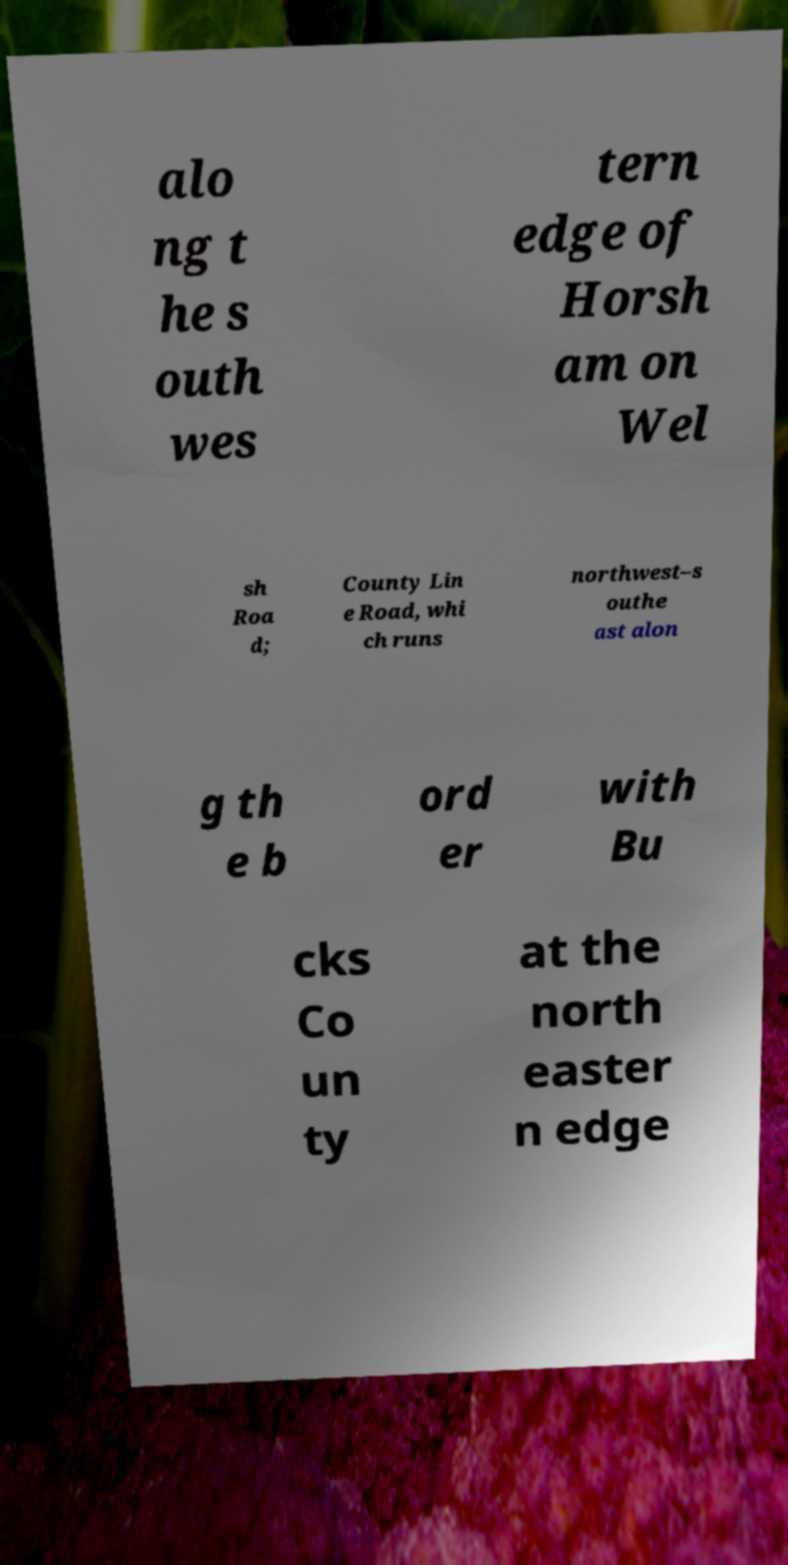Please read and relay the text visible in this image. What does it say? alo ng t he s outh wes tern edge of Horsh am on Wel sh Roa d; County Lin e Road, whi ch runs northwest–s outhe ast alon g th e b ord er with Bu cks Co un ty at the north easter n edge 